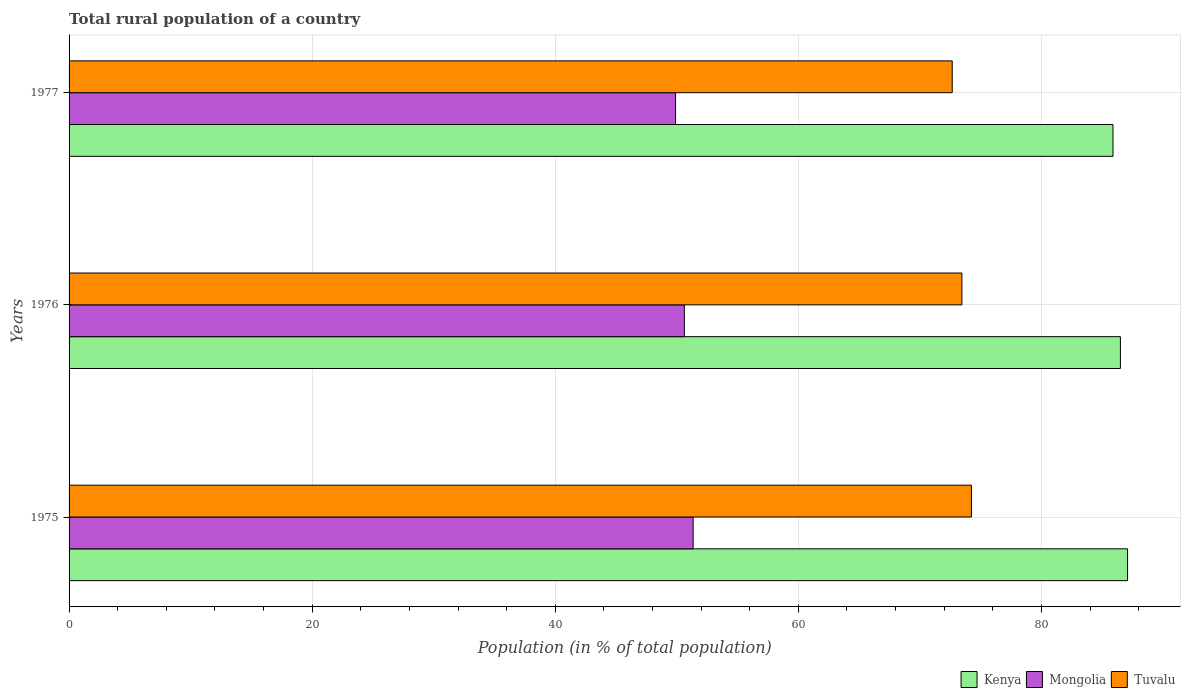How many different coloured bars are there?
Provide a succinct answer. 3. How many groups of bars are there?
Provide a short and direct response. 3. Are the number of bars per tick equal to the number of legend labels?
Keep it short and to the point. Yes. How many bars are there on the 2nd tick from the top?
Make the answer very short. 3. What is the label of the 3rd group of bars from the top?
Provide a succinct answer. 1975. What is the rural population in Kenya in 1977?
Ensure brevity in your answer.  85.89. Across all years, what is the maximum rural population in Kenya?
Offer a terse response. 87.09. Across all years, what is the minimum rural population in Tuvalu?
Make the answer very short. 72.66. In which year was the rural population in Tuvalu maximum?
Your answer should be compact. 1975. What is the total rural population in Kenya in the graph?
Offer a terse response. 259.47. What is the difference between the rural population in Mongolia in 1976 and that in 1977?
Make the answer very short. 0.72. What is the difference between the rural population in Kenya in 1975 and the rural population in Mongolia in 1976?
Your answer should be compact. 36.47. What is the average rural population in Tuvalu per year?
Make the answer very short. 73.45. In the year 1976, what is the difference between the rural population in Tuvalu and rural population in Kenya?
Your response must be concise. -13.04. In how many years, is the rural population in Mongolia greater than 16 %?
Provide a short and direct response. 3. What is the ratio of the rural population in Kenya in 1975 to that in 1976?
Provide a succinct answer. 1.01. Is the rural population in Mongolia in 1975 less than that in 1976?
Keep it short and to the point. No. Is the difference between the rural population in Tuvalu in 1976 and 1977 greater than the difference between the rural population in Kenya in 1976 and 1977?
Offer a terse response. Yes. What is the difference between the highest and the second highest rural population in Tuvalu?
Your answer should be compact. 0.78. What is the difference between the highest and the lowest rural population in Kenya?
Offer a terse response. 1.2. What does the 1st bar from the top in 1977 represents?
Provide a short and direct response. Tuvalu. What does the 2nd bar from the bottom in 1977 represents?
Make the answer very short. Mongolia. What is the difference between two consecutive major ticks on the X-axis?
Your answer should be compact. 20. Does the graph contain grids?
Make the answer very short. Yes. Where does the legend appear in the graph?
Provide a succinct answer. Bottom right. How many legend labels are there?
Your response must be concise. 3. What is the title of the graph?
Offer a very short reply. Total rural population of a country. What is the label or title of the X-axis?
Provide a short and direct response. Population (in % of total population). What is the Population (in % of total population) of Kenya in 1975?
Keep it short and to the point. 87.09. What is the Population (in % of total population) in Mongolia in 1975?
Ensure brevity in your answer.  51.34. What is the Population (in % of total population) in Tuvalu in 1975?
Ensure brevity in your answer.  74.24. What is the Population (in % of total population) in Kenya in 1976?
Offer a terse response. 86.5. What is the Population (in % of total population) of Mongolia in 1976?
Ensure brevity in your answer.  50.62. What is the Population (in % of total population) of Tuvalu in 1976?
Give a very brief answer. 73.45. What is the Population (in % of total population) of Kenya in 1977?
Make the answer very short. 85.89. What is the Population (in % of total population) of Mongolia in 1977?
Provide a short and direct response. 49.9. What is the Population (in % of total population) in Tuvalu in 1977?
Provide a succinct answer. 72.66. Across all years, what is the maximum Population (in % of total population) of Kenya?
Provide a short and direct response. 87.09. Across all years, what is the maximum Population (in % of total population) of Mongolia?
Offer a very short reply. 51.34. Across all years, what is the maximum Population (in % of total population) of Tuvalu?
Provide a succinct answer. 74.24. Across all years, what is the minimum Population (in % of total population) of Kenya?
Give a very brief answer. 85.89. Across all years, what is the minimum Population (in % of total population) of Mongolia?
Your answer should be compact. 49.9. Across all years, what is the minimum Population (in % of total population) in Tuvalu?
Offer a terse response. 72.66. What is the total Population (in % of total population) in Kenya in the graph?
Your response must be concise. 259.47. What is the total Population (in % of total population) of Mongolia in the graph?
Give a very brief answer. 151.86. What is the total Population (in % of total population) in Tuvalu in the graph?
Provide a succinct answer. 220.35. What is the difference between the Population (in % of total population) in Kenya in 1975 and that in 1976?
Provide a succinct answer. 0.59. What is the difference between the Population (in % of total population) of Mongolia in 1975 and that in 1976?
Your response must be concise. 0.72. What is the difference between the Population (in % of total population) in Tuvalu in 1975 and that in 1976?
Provide a succinct answer. 0.78. What is the difference between the Population (in % of total population) in Kenya in 1975 and that in 1977?
Give a very brief answer. 1.2. What is the difference between the Population (in % of total population) of Mongolia in 1975 and that in 1977?
Your answer should be very brief. 1.45. What is the difference between the Population (in % of total population) in Tuvalu in 1975 and that in 1977?
Provide a short and direct response. 1.58. What is the difference between the Population (in % of total population) of Kenya in 1976 and that in 1977?
Ensure brevity in your answer.  0.61. What is the difference between the Population (in % of total population) of Mongolia in 1976 and that in 1977?
Give a very brief answer. 0.72. What is the difference between the Population (in % of total population) in Tuvalu in 1976 and that in 1977?
Offer a very short reply. 0.8. What is the difference between the Population (in % of total population) of Kenya in 1975 and the Population (in % of total population) of Mongolia in 1976?
Give a very brief answer. 36.47. What is the difference between the Population (in % of total population) in Kenya in 1975 and the Population (in % of total population) in Tuvalu in 1976?
Offer a very short reply. 13.63. What is the difference between the Population (in % of total population) of Mongolia in 1975 and the Population (in % of total population) of Tuvalu in 1976?
Provide a short and direct response. -22.11. What is the difference between the Population (in % of total population) of Kenya in 1975 and the Population (in % of total population) of Mongolia in 1977?
Your answer should be very brief. 37.19. What is the difference between the Population (in % of total population) in Kenya in 1975 and the Population (in % of total population) in Tuvalu in 1977?
Provide a succinct answer. 14.43. What is the difference between the Population (in % of total population) of Mongolia in 1975 and the Population (in % of total population) of Tuvalu in 1977?
Ensure brevity in your answer.  -21.32. What is the difference between the Population (in % of total population) in Kenya in 1976 and the Population (in % of total population) in Mongolia in 1977?
Ensure brevity in your answer.  36.6. What is the difference between the Population (in % of total population) of Kenya in 1976 and the Population (in % of total population) of Tuvalu in 1977?
Your answer should be very brief. 13.84. What is the difference between the Population (in % of total population) in Mongolia in 1976 and the Population (in % of total population) in Tuvalu in 1977?
Make the answer very short. -22.04. What is the average Population (in % of total population) of Kenya per year?
Your response must be concise. 86.49. What is the average Population (in % of total population) of Mongolia per year?
Offer a very short reply. 50.62. What is the average Population (in % of total population) in Tuvalu per year?
Provide a short and direct response. 73.45. In the year 1975, what is the difference between the Population (in % of total population) of Kenya and Population (in % of total population) of Mongolia?
Make the answer very short. 35.74. In the year 1975, what is the difference between the Population (in % of total population) in Kenya and Population (in % of total population) in Tuvalu?
Provide a short and direct response. 12.85. In the year 1975, what is the difference between the Population (in % of total population) in Mongolia and Population (in % of total population) in Tuvalu?
Give a very brief answer. -22.89. In the year 1976, what is the difference between the Population (in % of total population) in Kenya and Population (in % of total population) in Mongolia?
Keep it short and to the point. 35.88. In the year 1976, what is the difference between the Population (in % of total population) in Kenya and Population (in % of total population) in Tuvalu?
Ensure brevity in your answer.  13.04. In the year 1976, what is the difference between the Population (in % of total population) of Mongolia and Population (in % of total population) of Tuvalu?
Offer a very short reply. -22.84. In the year 1977, what is the difference between the Population (in % of total population) of Kenya and Population (in % of total population) of Mongolia?
Make the answer very short. 35.99. In the year 1977, what is the difference between the Population (in % of total population) in Kenya and Population (in % of total population) in Tuvalu?
Provide a short and direct response. 13.23. In the year 1977, what is the difference between the Population (in % of total population) in Mongolia and Population (in % of total population) in Tuvalu?
Your response must be concise. -22.76. What is the ratio of the Population (in % of total population) of Kenya in 1975 to that in 1976?
Your answer should be compact. 1.01. What is the ratio of the Population (in % of total population) in Mongolia in 1975 to that in 1976?
Your answer should be very brief. 1.01. What is the ratio of the Population (in % of total population) of Tuvalu in 1975 to that in 1976?
Make the answer very short. 1.01. What is the ratio of the Population (in % of total population) in Kenya in 1975 to that in 1977?
Make the answer very short. 1.01. What is the ratio of the Population (in % of total population) in Tuvalu in 1975 to that in 1977?
Offer a very short reply. 1.02. What is the ratio of the Population (in % of total population) in Kenya in 1976 to that in 1977?
Offer a terse response. 1.01. What is the ratio of the Population (in % of total population) in Mongolia in 1976 to that in 1977?
Provide a short and direct response. 1.01. What is the difference between the highest and the second highest Population (in % of total population) of Kenya?
Your answer should be compact. 0.59. What is the difference between the highest and the second highest Population (in % of total population) in Mongolia?
Make the answer very short. 0.72. What is the difference between the highest and the second highest Population (in % of total population) of Tuvalu?
Provide a succinct answer. 0.78. What is the difference between the highest and the lowest Population (in % of total population) in Kenya?
Ensure brevity in your answer.  1.2. What is the difference between the highest and the lowest Population (in % of total population) of Mongolia?
Provide a short and direct response. 1.45. What is the difference between the highest and the lowest Population (in % of total population) of Tuvalu?
Offer a very short reply. 1.58. 